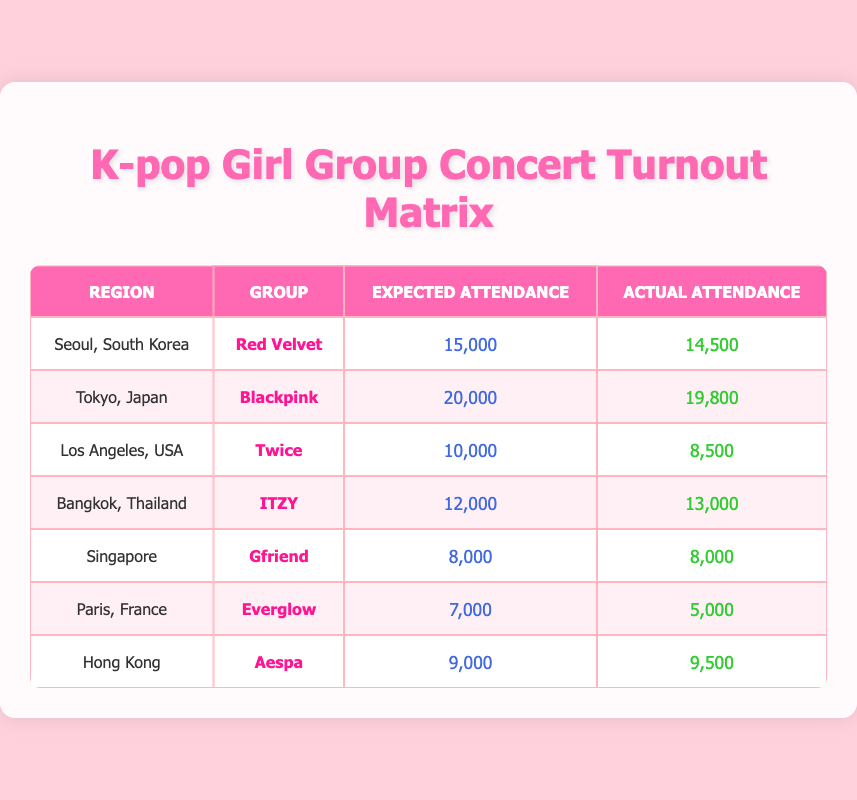What was the actual attendance for the concert in Seoul? The actual attendance for the concert in Seoul is listed directly in the table under the "Actual Attendance" column for that region. It shows 14,500 attendees.
Answer: 14,500 Which K-pop girl group performed in Paris, France? The table specifies that Everglow performed in Paris, France, as identified in the "Group" column for that region.
Answer: Everglow How many concerts had actual attendance less than expected attendance? To find this, we must examine each row and compare the actual attendance with expected attendance. The concerts in Los Angeles and Paris had lower actual attendance than expected (8,500 < 10,000 and 5,000 < 7,000), resulting in 2 concerts.
Answer: 2 What is the difference in attendance between the expected and actual attendance for ITZY's concert in Bangkok? For ITZY's concert, the expected attendance was 12,000 and the actual attendance was 13,000. The difference is calculated by subtracting the expected number from the actual: 13,000 - 12,000 = 1,000.
Answer: 1,000 Did Aespa's concert in Hong Kong meet or exceed the expected attendance? By looking at Aespa's row in the table, expected attendance is 9,000 and actual attendance is 9,500. Since the actual attendance is greater than the expected, the answer is yes.
Answer: Yes What is the total expected attendance for all concerts listed? To determine the total expected attendance, we sum up all the expected values: 15,000 + 20,000 + 10,000 + 12,000 + 8,000 + 7,000 + 9,000 = 91,000.
Answer: 91,000 Which concert had the highest actual attendance? We can identify the maximum value in the "Actual Attendance" column by reviewing the data. The highest attendance is from ITZY in Bangkok with 13,000 attendees.
Answer: ITZY in Bangkok What percentage of the expected attendance did Gfriend achieve in Singapore? Gfriend had an expected attendance of 8,000 and an actual of 8,000. To find the percentage, we calculate (8,000 / 8,000) * 100 = 100%.
Answer: 100% 